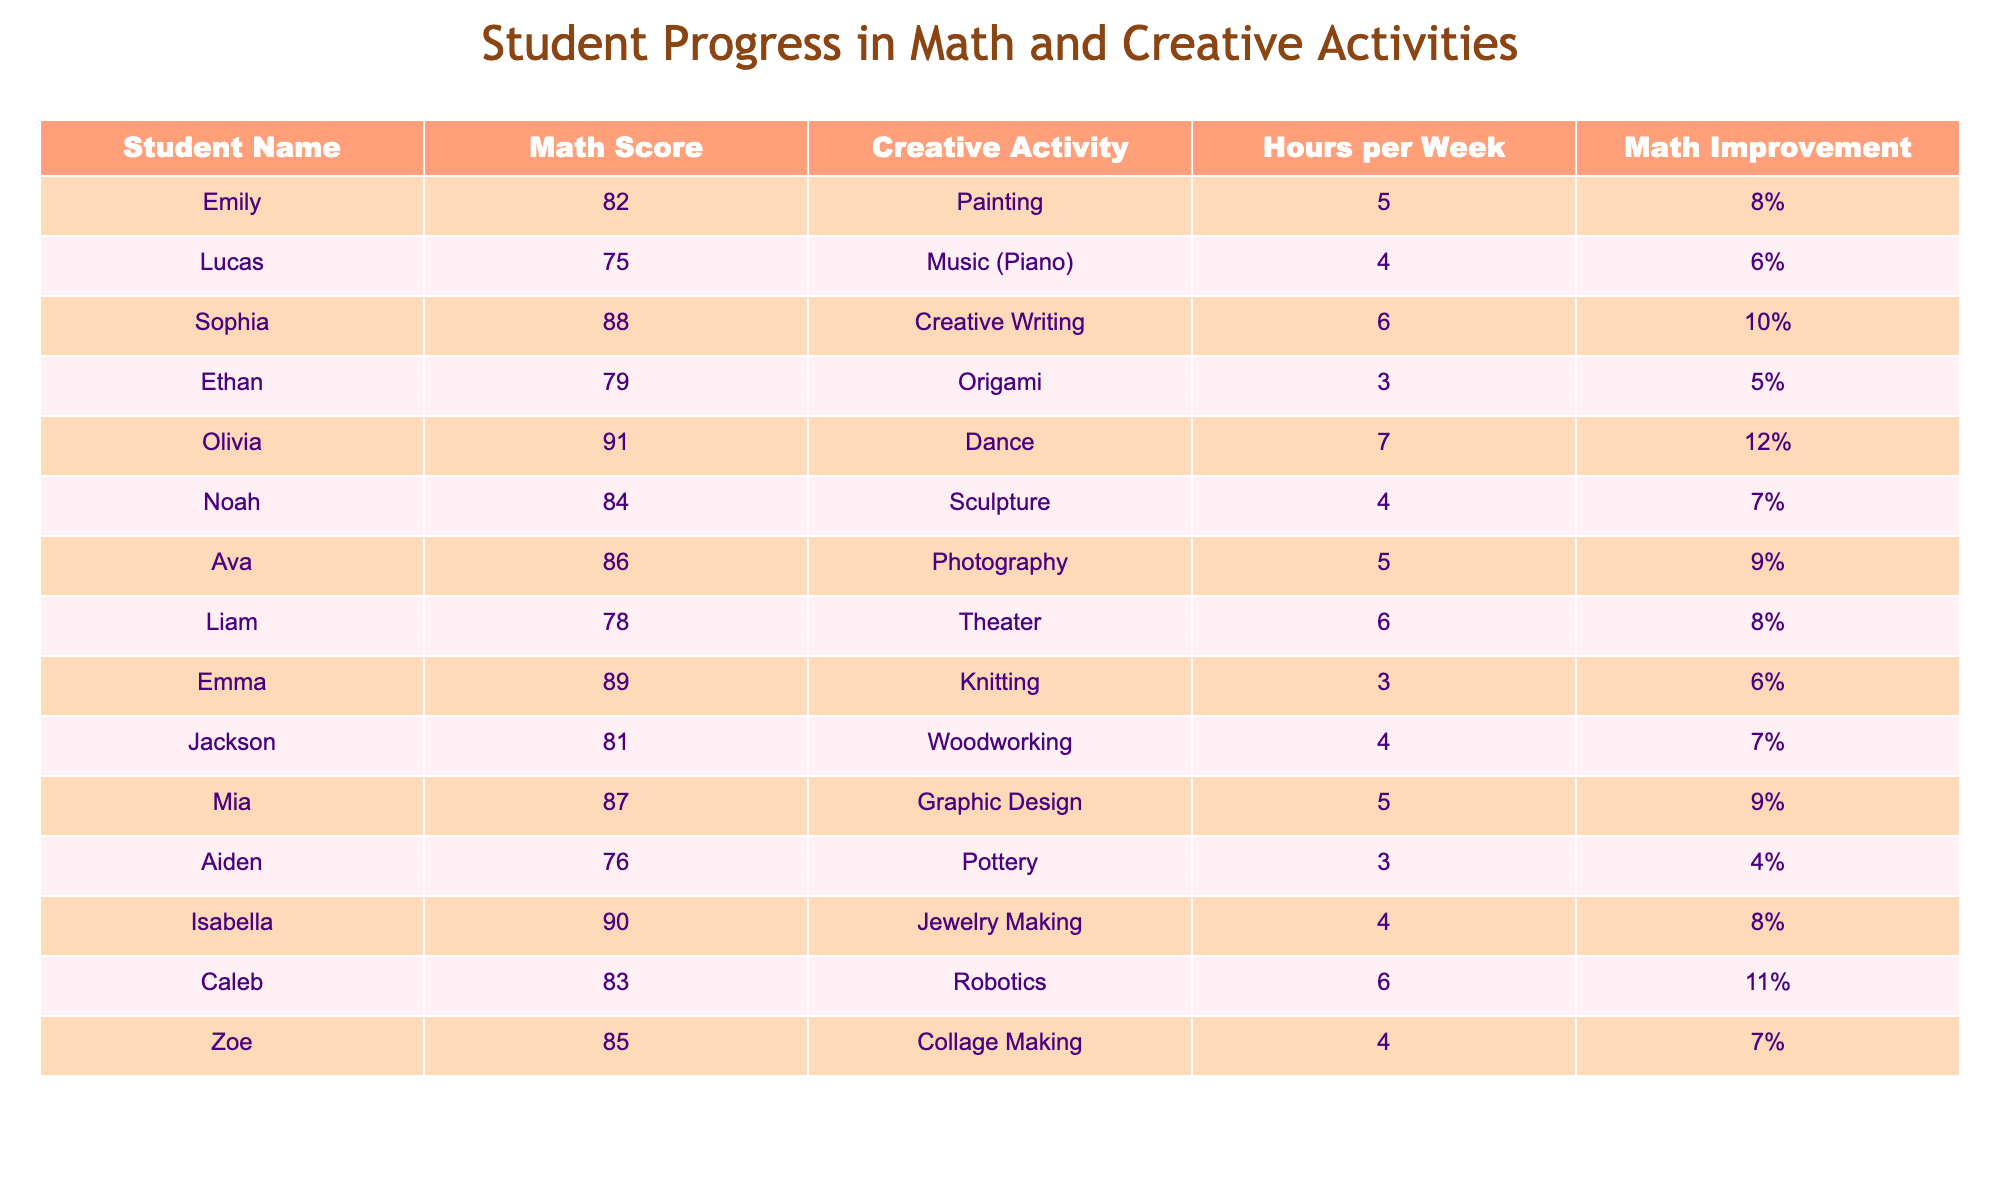What is the Math Score of Olivia? Olivia's Math Score is listed directly in the table. Looking at the entry for Olivia, her Math Score is 91.
Answer: 91 Which student has the highest Math Improvement? To determine which student has the highest Math Improvement, we compare the values in the Math Improvement column. Olivia has the highest improvement at 12%.
Answer: Olivia What is the average Math Score of all students? To find the average, sum the Math Scores of all students: 82 + 75 + 88 + 79 + 91 + 84 + 86 + 78 + 89 + 81 + 87 + 76 + 90 + 83 + 85 = 1317. There are 15 students, so the average score is 1317/15 = 87.8.
Answer: 87.8 How many students participate in Dance as a creative activity? The table shows one student participating in Dance, which is Olivia.
Answer: 1 Is there a student whose Math Improvement is 4%? By examining the Math Improvement column, Aiden’s improvement is listed as 4%, confirming that there is indeed a student meeting this criterion.
Answer: Yes What is the total improvement percentage of all students combined? The total improvement percentage can be calculated by adding all individual improvements: 8 + 6 + 10 + 5 + 12 + 7 + 9 + 8 + 6 + 7 + 9 + 4 + 8 + 11 + 7 = 141. Thus, the total improvement percentage is 141%.
Answer: 141% Which student participates in Pottery and what is their Math Score? Aiden is the student who participates in Pottery, and his Math Score is 76 as seen in his row in the table.
Answer: Aiden, 76 Are there students whose Math Score is above 85? By reviewing the Math Score column, students who scored above 85 are Emily, Sophia, Olivia, Ava, Mia, Isabella, and Caleb. Thus, there are multiple students above this score.
Answer: Yes What is the lowest Math Score among the students? We examine the Math Scores in the table to find the lowest score. Aiden has the lowest score of 76.
Answer: 76 What is the relationship between the average hours spent on creative activities and their Math Scores? To determine this, we need to calculate the average hours spent on creative activities (5.0 hours) and correlate that with the average Math Score (87.8).  This requires a more qualitative interpretation of values but generally implies that students engaging in more creative activities show higher Math Scores. This can indicate a possible positive relationship.
Answer: Positive relationship suggested 